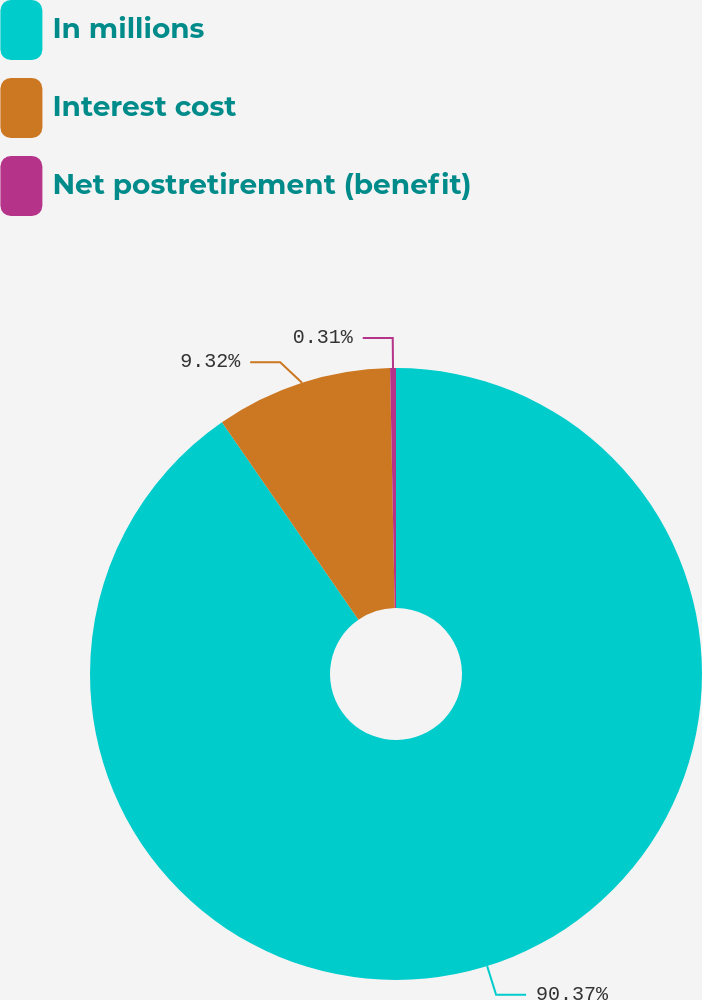<chart> <loc_0><loc_0><loc_500><loc_500><pie_chart><fcel>In millions<fcel>Interest cost<fcel>Net postretirement (benefit)<nl><fcel>90.37%<fcel>9.32%<fcel>0.31%<nl></chart> 